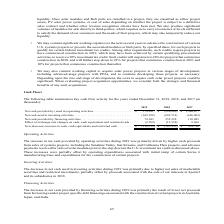According to First Solar's financial document, What are the reasons for the increase in cash provided by operating activities in 2019? primarily driven by higher cash proceeds from sales of systems projects, including the Sunshine Valley, Sun Streams, and California Flats projects, and advance payments received for sales of solar modules prior to the step down in the U.S. investment tax credit as discussed above.. The document states: "h provided by operating activities during 2019 was primarily driven by higher cash proceeds from sales of systems projects, including the Sunshine Val..." Also, What are the reasons for the decrease in cash used in investing activities? The decrease in net cash used in investing activities during 2019 was primarily due to higher net sales of marketable securities and restricted investments, partially offset by proceeds associated with the sale of our interests in 8point3 and its subsidiaries in 2018.. The document states: "The decrease in net cash used in investing activities during 2019 was primarily due to higher net sales of marketable securities and restricted invest..." Also, What are the reasons for the decrease in cash provided by financing activities? The decrease in net cash provided by financing activities during 2019 was primarily the result of lower net proceeds from borrowings under project specific debt financings associated with the construction of certain projects in Australia, Japan, and India.. The document states: "The decrease in net cash provided by financing activities during 2019 was primarily the result of lower net proceeds from borrowings under project spe..." Also, can you calculate: What is the increase in cash provided by operating activities from 2018 to 2019? Based on the calculation: 174,201 - (-326,809) , the result is 501010 (in thousands). This is based on the information: "sh provided by (used in) operating activities . $ 174,201 $ (326,809) $ 1,340,677 Net cash used in investing activities . (362,298) (682,714) (626,802) Net c by (used in) operating activities . $ 174,..." The key data points involved are: 174,201, 326,809. Also, can you calculate: What is the difference in net cash and cash equivalents between 2019 and 2018? Based on the calculation:  (-116,113) - (-767,853) , the result is 651740 (in thousands). This is based on the information: "equivalents and restricted cash . $ (116,113) $ (767,853) $ 914,786 n cash, cash equivalents and restricted cash . $ (116,113) $ (767,853) $ 914,786..." The key data points involved are: 116,113, 767,853. Also, can you calculate: What is the percentage decrease in cash provided in financing activities from 2018 to 2019? To answer this question, I need to perform calculations using the financial data. The calculation is: (255,228 - 74,943) / 255,228 , which equals 70.64 (percentage). This is based on the information: ",802) Net cash provided by financing activities . 74,943 255,228 192,045 Effect of exchange rate changes on cash, cash equivalents and restricted cash . (2, et cash provided by financing activities . ..." The key data points involved are: 255,228, 74,943. 